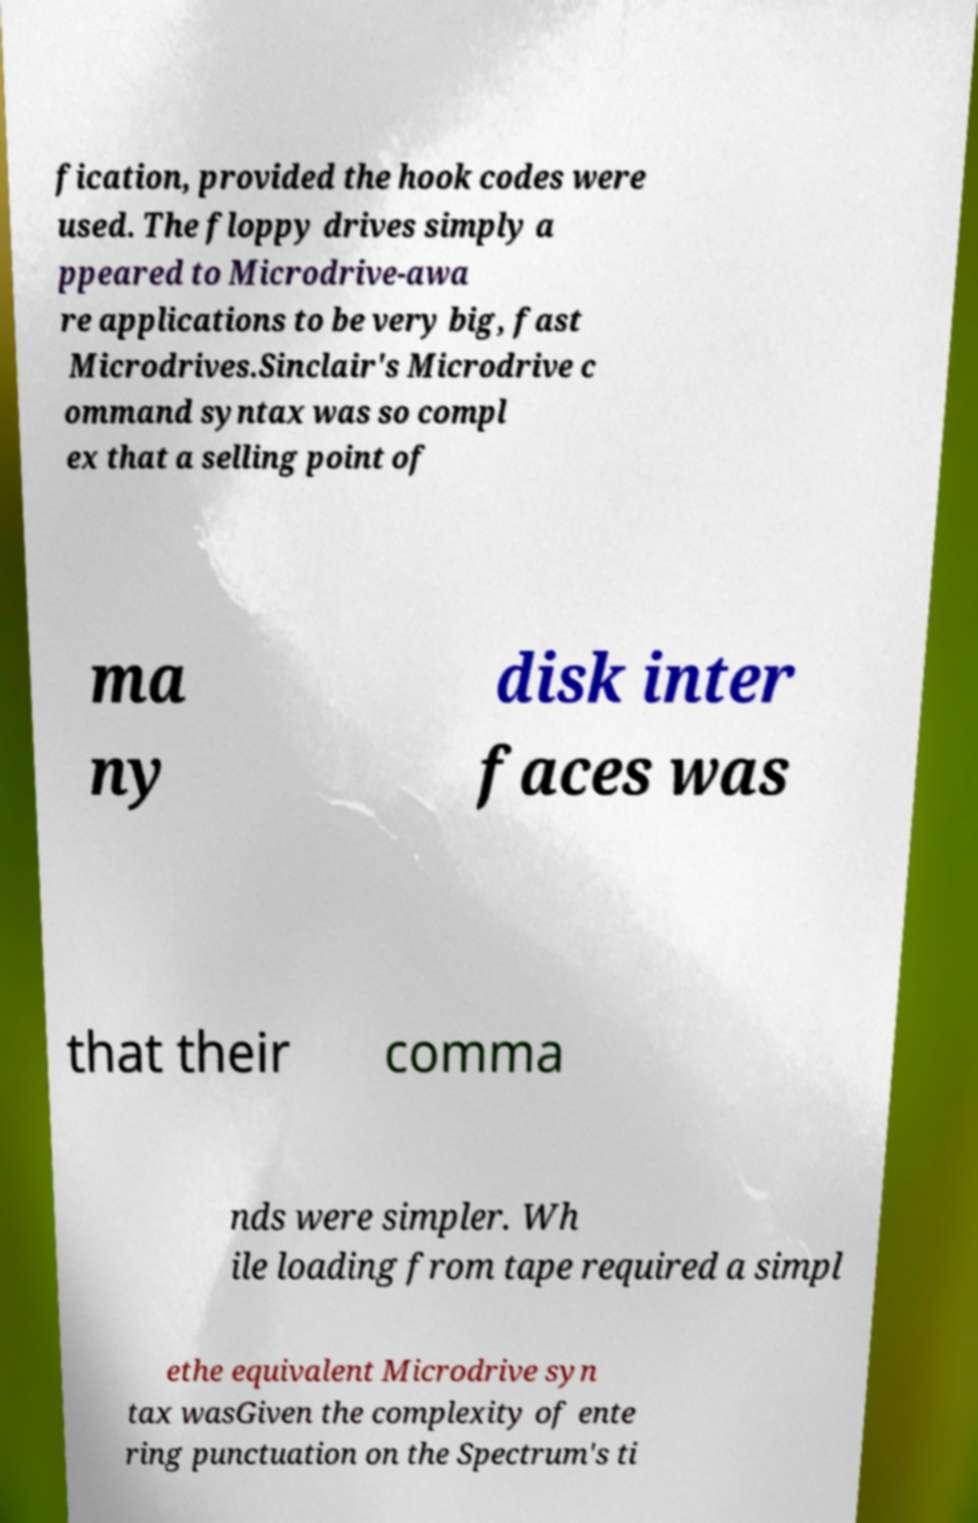Could you extract and type out the text from this image? fication, provided the hook codes were used. The floppy drives simply a ppeared to Microdrive-awa re applications to be very big, fast Microdrives.Sinclair's Microdrive c ommand syntax was so compl ex that a selling point of ma ny disk inter faces was that their comma nds were simpler. Wh ile loading from tape required a simpl ethe equivalent Microdrive syn tax wasGiven the complexity of ente ring punctuation on the Spectrum's ti 